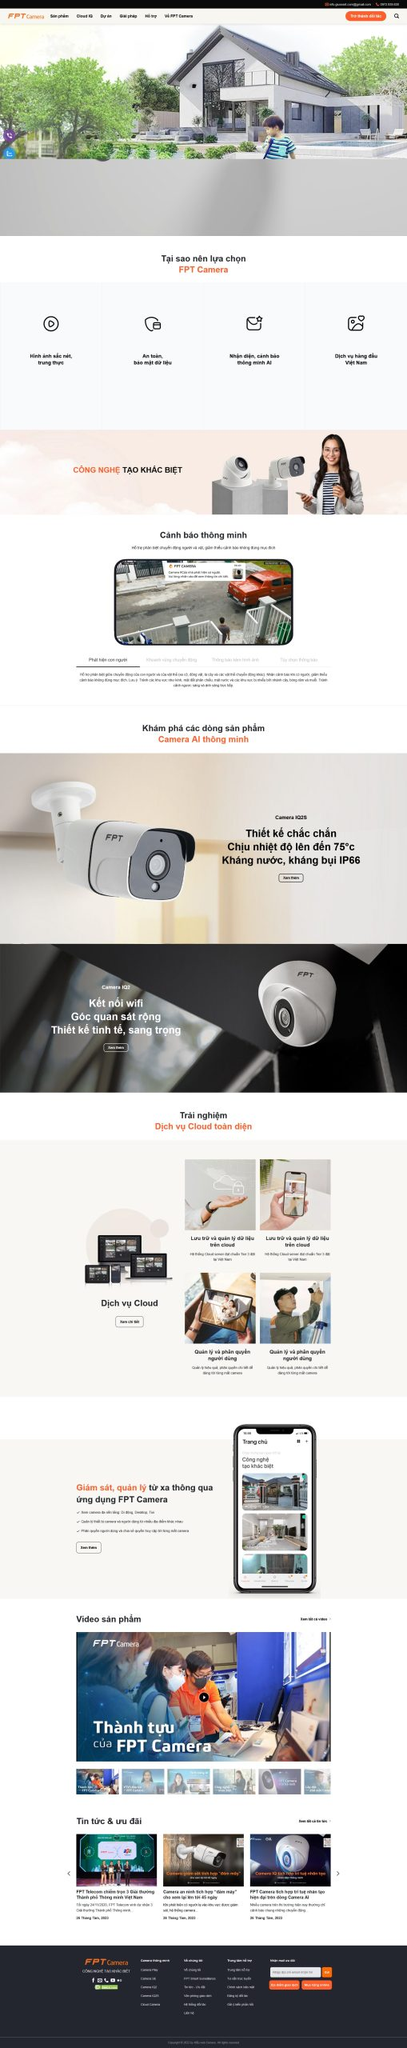Viết một bài viết giới thiệu giao diện website này của DPS MEDIA bao gồm ngành nghề, kiểu dáng, màu sắc, tính năng, bố cục,...Nhưng không nhắc lại liên kết hình ảnh trong bài viết.
 **Giới thiệu giao diện website của DPS MEDIA**

Website của DPS MEDIA được thiết kế hiện đại và tinh tế, phù hợp với ngành nghề cung cấp các giải pháp camera an ninh. 

**Ngành nghề:**
Website tập trung vào lĩnh vực kinh doanh và cung cấp các sản phẩm camera an ninh thông minh, với các tính năng tiên tiến giúp người dùng dễ dàng giám sát và bảo vệ tài sản của mình.

**Kiểu dáng và màu sắc:**
Giao diện website được thiết kế với tông màu trắng chủ đạo, kết hợp với các điểm nhấn màu cam và đen, tạo cảm giác chuyên nghiệp và hiện đại. Hình ảnh và biểu tượng được sử dụng sắc nét, rõ ràng, giúp người dùng dễ dàng nhận diện và tương tác.

**Tính năng:**
Website cung cấp nhiều tính năng hữu ích như:
- Giới thiệu sản phẩm và giải pháp camera an ninh với các thông số kỹ thuật chi tiết.
- Chức năng cảnh báo thông minh và tính năng kết nối wifi.
- Dịch vụ Cloud giúp lưu trữ và quản lý dữ liệu từ xa.
- Video sản phẩm và các thành tựu của công ty.
- Tin tức và ưu đãi mới nhất về sản phẩm và dịch vụ.

**Bố cục:**
Bố cục website được sắp xếp một cách khoa học và hợp lý:
- Phần đầu trang là logo và thanh menu điều hướng, cùng với nút tìm kiếm và giỏ hàng.
- Phần trung tâm là các banner lớn giới thiệu sản phẩm nổi bật và lý do nên chọn FPT Camera.
- Phần tiếp theo là các tính năng nổi bật của sản phẩm, dịch vụ Cloud và các video minh họa.
- Phần cuối trang là thông tin liên hệ, các đối tác và các liên kết mạng xã hội.

Website của DPS MEDIA không chỉ mang lại trải nghiệm người dùng tốt mà còn thể hiện sự chuyên nghiệp và uy tín trong lĩnh vực cung cấp giải pháp an ninh. 